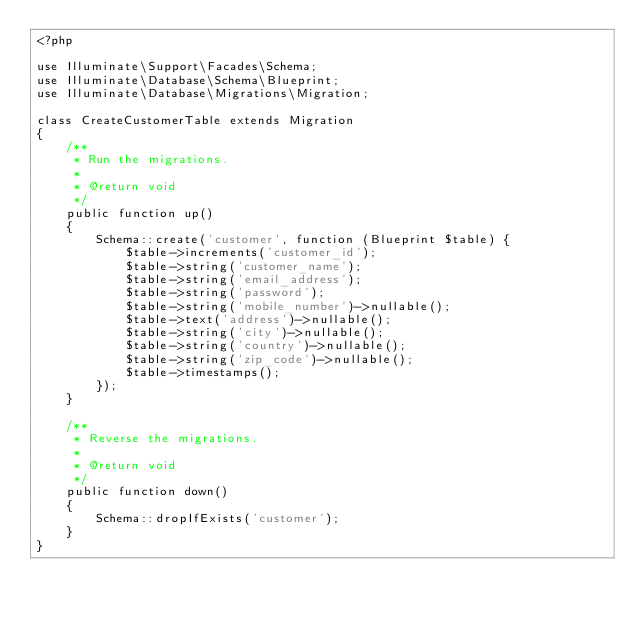Convert code to text. <code><loc_0><loc_0><loc_500><loc_500><_PHP_><?php

use Illuminate\Support\Facades\Schema;
use Illuminate\Database\Schema\Blueprint;
use Illuminate\Database\Migrations\Migration;

class CreateCustomerTable extends Migration
{
    /**
     * Run the migrations.
     *
     * @return void
     */
    public function up()
    {
        Schema::create('customer', function (Blueprint $table) {
            $table->increments('customer_id');
            $table->string('customer_name');
            $table->string('email_address');
            $table->string('password');
            $table->string('mobile_number')->nullable();
            $table->text('address')->nullable();
            $table->string('city')->nullable();
            $table->string('country')->nullable();
            $table->string('zip_code')->nullable();
            $table->timestamps();
        });
    }

    /**
     * Reverse the migrations.
     *
     * @return void
     */
    public function down()
    {
        Schema::dropIfExists('customer');
    }
}
</code> 